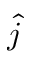<formula> <loc_0><loc_0><loc_500><loc_500>\hat { j }</formula> 